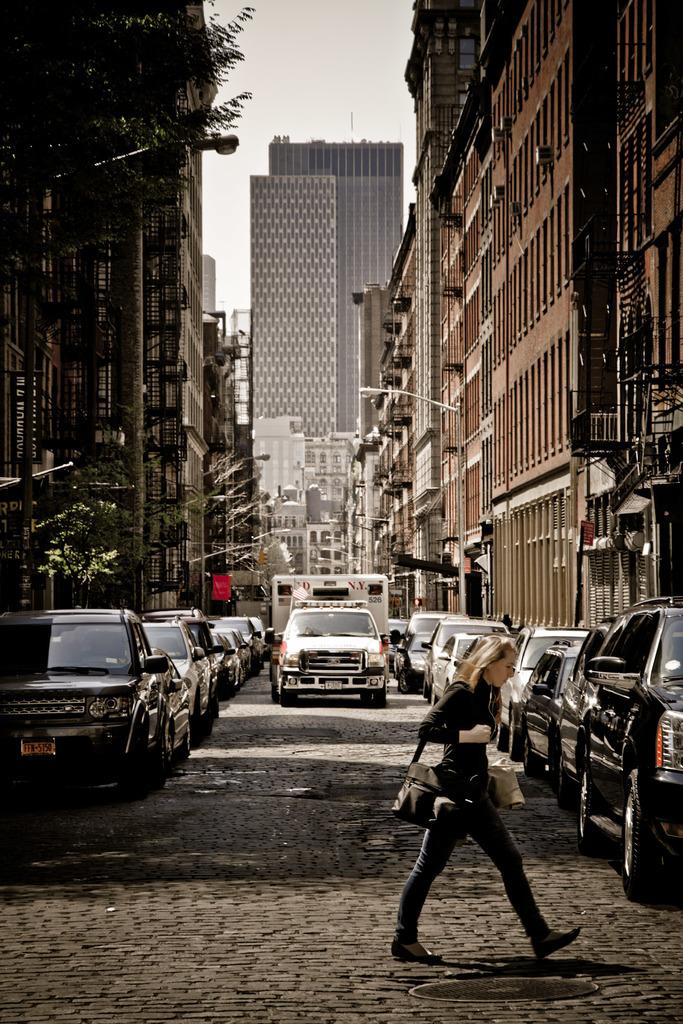What is the ambulance number?
Give a very brief answer. 526. What city is the ambulance from?
Your answer should be very brief. New york. 